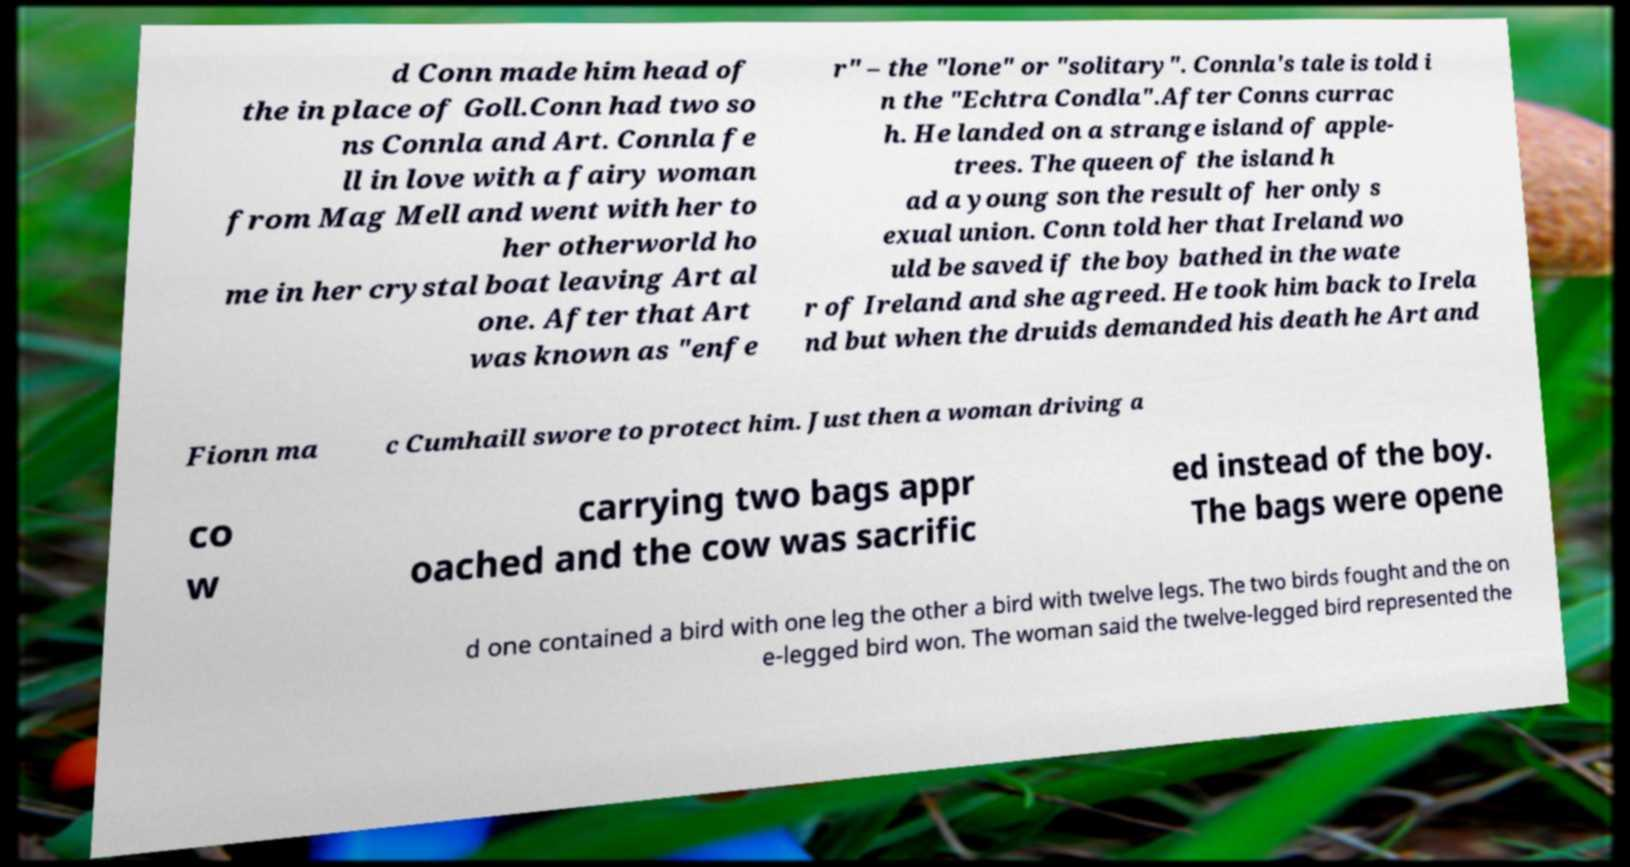Can you accurately transcribe the text from the provided image for me? d Conn made him head of the in place of Goll.Conn had two so ns Connla and Art. Connla fe ll in love with a fairy woman from Mag Mell and went with her to her otherworld ho me in her crystal boat leaving Art al one. After that Art was known as "enfe r" – the "lone" or "solitary". Connla's tale is told i n the "Echtra Condla".After Conns currac h. He landed on a strange island of apple- trees. The queen of the island h ad a young son the result of her only s exual union. Conn told her that Ireland wo uld be saved if the boy bathed in the wate r of Ireland and she agreed. He took him back to Irela nd but when the druids demanded his death he Art and Fionn ma c Cumhaill swore to protect him. Just then a woman driving a co w carrying two bags appr oached and the cow was sacrific ed instead of the boy. The bags were opene d one contained a bird with one leg the other a bird with twelve legs. The two birds fought and the on e-legged bird won. The woman said the twelve-legged bird represented the 